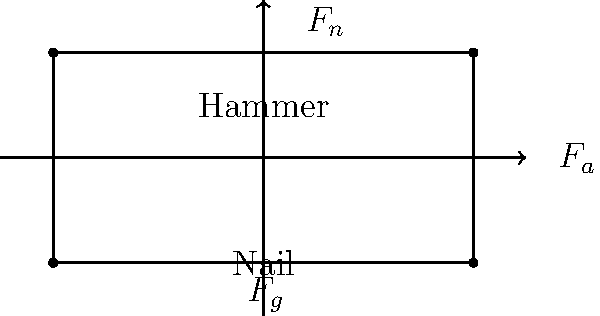Your father is demonstrating the proper technique for hammering nails. As the hammer strikes the nail, what are the primary forces acting on the hammer, and how do they relate to Newton's laws of motion? To understand the forces acting on the hammer when striking a nail, let's break it down step-by-step:

1. Forces acting on the hammer:
   a) Gravitational force ($F_g$): Pulls the hammer downward
   b) Normal force ($F_n$): Exerted by the nail on the hammer, opposing the impact
   c) Applied force ($F_a$): The force your father applies to swing the hammer

2. Newton's First Law: An object remains at rest or in uniform motion unless acted upon by an external force.
   - Initially, the hammer is at rest or in motion due to your father's applied force.
   - The impact with the nail changes the hammer's motion, demonstrating the effect of external forces.

3. Newton's Second Law: $F = ma$
   - The net force on the hammer during impact is the sum of all forces: $F_{net} = F_a + F_g - F_n$
   - This net force causes the hammer to decelerate rapidly upon impact.

4. Newton's Third Law: For every action, there is an equal and opposite reaction.
   - The force the hammer exerts on the nail is equal and opposite to the force the nail exerts back on the hammer ($F_n$).

5. Energy transfer:
   - The kinetic energy of the hammer is transferred to the nail, driving it into the wood.
   - Some energy is also converted to heat and sound during the impact.

6. Impulse:
   - The change in the hammer's momentum is equal to the impulse (force × time) applied during the brief impact.

Understanding these forces and principles helps in developing proper hammering technique, which your father, as a carpenter, likely emphasizes for efficiency and safety.
Answer: $F_g$ (gravity), $F_n$ (normal force from nail), $F_a$ (applied force); illustrate Newton's laws through motion changes, force-acceleration relationship, and action-reaction pairs. 